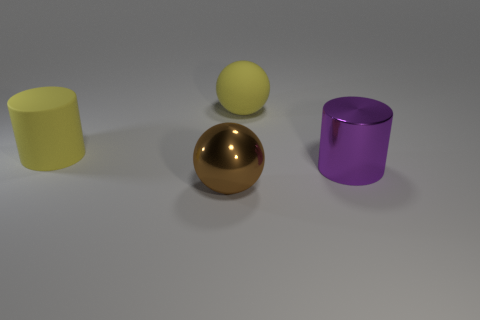There is a yellow object that is right of the yellow rubber cylinder; is it the same shape as the big object left of the big brown ball?
Your response must be concise. No. How many cubes are large metal objects or large yellow matte things?
Offer a terse response. 0. There is a big sphere in front of the big yellow rubber thing that is in front of the large yellow matte object behind the yellow cylinder; what is it made of?
Give a very brief answer. Metal. What number of other things are the same size as the yellow rubber sphere?
Provide a short and direct response. 3. There is a cylinder that is the same color as the rubber sphere; what size is it?
Your answer should be compact. Large. Is the number of big shiny things in front of the purple metallic object greater than the number of tiny green things?
Offer a terse response. Yes. Are there any spheres that have the same color as the large matte cylinder?
Keep it short and to the point. Yes. What color is the matte ball that is the same size as the purple thing?
Ensure brevity in your answer.  Yellow. There is a rubber object on the right side of the brown metal ball; how many large cylinders are behind it?
Your response must be concise. 0. How many things are either yellow matte objects that are to the left of the large brown metal thing or brown balls?
Your response must be concise. 2. 